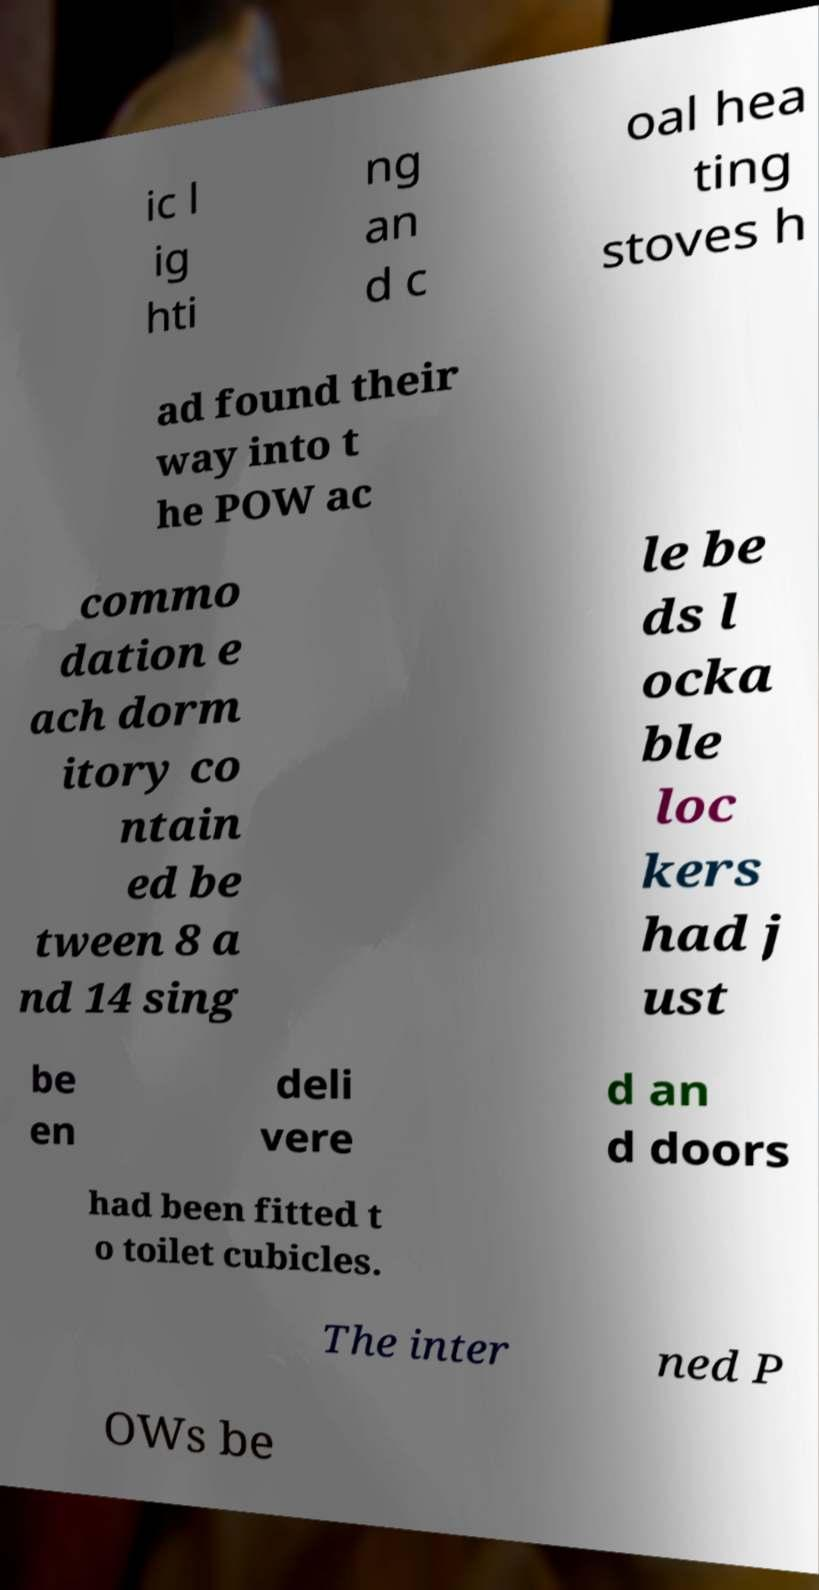What messages or text are displayed in this image? I need them in a readable, typed format. ic l ig hti ng an d c oal hea ting stoves h ad found their way into t he POW ac commo dation e ach dorm itory co ntain ed be tween 8 a nd 14 sing le be ds l ocka ble loc kers had j ust be en deli vere d an d doors had been fitted t o toilet cubicles. The inter ned P OWs be 